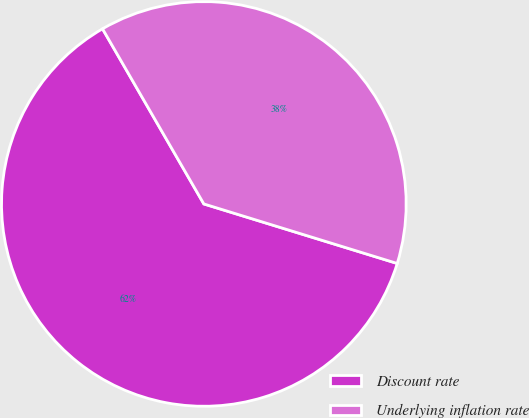Convert chart to OTSL. <chart><loc_0><loc_0><loc_500><loc_500><pie_chart><fcel>Discount rate<fcel>Underlying inflation rate<nl><fcel>61.9%<fcel>38.1%<nl></chart> 